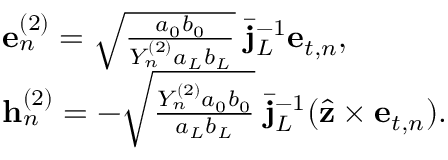<formula> <loc_0><loc_0><loc_500><loc_500>\begin{array} { r l } & { { e } _ { n } ^ { ( 2 ) } = \sqrt { \frac { a _ { 0 } b _ { 0 } } { Y _ { n } ^ { ( 2 ) } a _ { L } b _ { L } } } \, \bar { j } _ { L } ^ { - 1 } { e } _ { t , n } , } \\ & { { h } _ { n } ^ { ( 2 ) } = - \sqrt { \frac { Y _ { n } ^ { ( 2 ) } a _ { 0 } b _ { 0 } } { a _ { L } b _ { L } } } \, \bar { j } _ { L } ^ { - 1 } ( \hat { z } \times { e } _ { t , n } ) . } \end{array}</formula> 